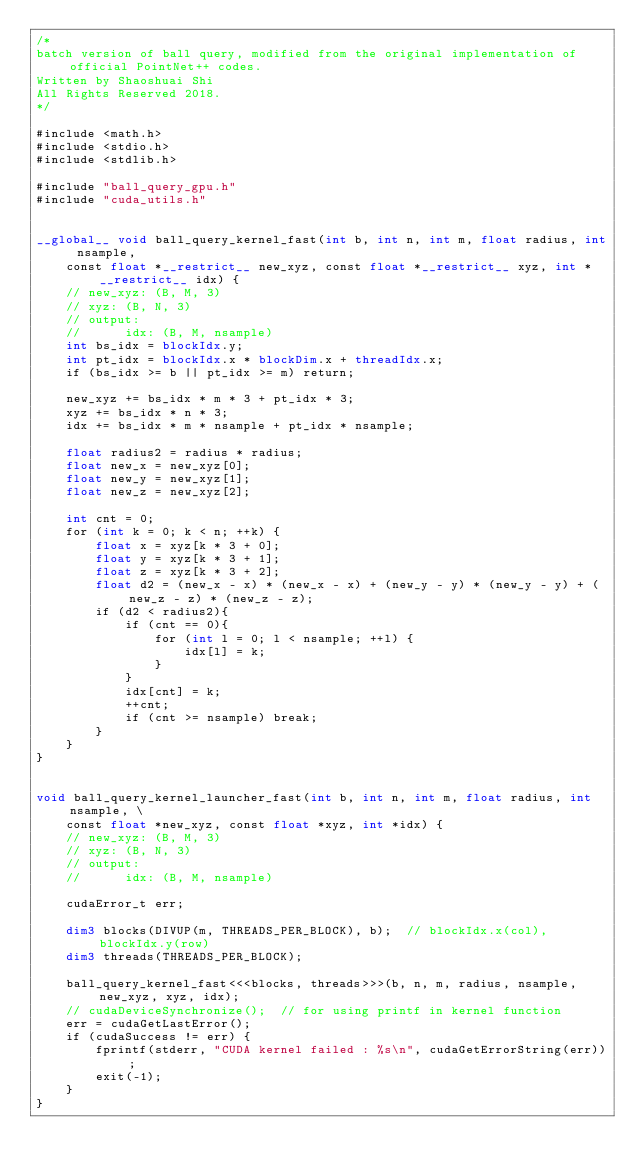Convert code to text. <code><loc_0><loc_0><loc_500><loc_500><_Cuda_>/*
batch version of ball query, modified from the original implementation of official PointNet++ codes.
Written by Shaoshuai Shi
All Rights Reserved 2018.
*/

#include <math.h>
#include <stdio.h>
#include <stdlib.h>

#include "ball_query_gpu.h"
#include "cuda_utils.h"


__global__ void ball_query_kernel_fast(int b, int n, int m, float radius, int nsample, 
    const float *__restrict__ new_xyz, const float *__restrict__ xyz, int *__restrict__ idx) {
    // new_xyz: (B, M, 3)
    // xyz: (B, N, 3)
    // output:
    //      idx: (B, M, nsample)
    int bs_idx = blockIdx.y;
    int pt_idx = blockIdx.x * blockDim.x + threadIdx.x;
    if (bs_idx >= b || pt_idx >= m) return;

    new_xyz += bs_idx * m * 3 + pt_idx * 3;
    xyz += bs_idx * n * 3;
    idx += bs_idx * m * nsample + pt_idx * nsample;

    float radius2 = radius * radius;
    float new_x = new_xyz[0];
    float new_y = new_xyz[1];
    float new_z = new_xyz[2];

    int cnt = 0;
    for (int k = 0; k < n; ++k) {
        float x = xyz[k * 3 + 0];
        float y = xyz[k * 3 + 1];
        float z = xyz[k * 3 + 2];
        float d2 = (new_x - x) * (new_x - x) + (new_y - y) * (new_y - y) + (new_z - z) * (new_z - z);
        if (d2 < radius2){
            if (cnt == 0){
                for (int l = 0; l < nsample; ++l) {
                    idx[l] = k;
                }
            }
            idx[cnt] = k;
            ++cnt;
            if (cnt >= nsample) break;
        }
    }
}


void ball_query_kernel_launcher_fast(int b, int n, int m, float radius, int nsample, \
    const float *new_xyz, const float *xyz, int *idx) {
    // new_xyz: (B, M, 3)
    // xyz: (B, N, 3)
    // output:
    //      idx: (B, M, nsample)

    cudaError_t err;

    dim3 blocks(DIVUP(m, THREADS_PER_BLOCK), b);  // blockIdx.x(col), blockIdx.y(row)
    dim3 threads(THREADS_PER_BLOCK);

    ball_query_kernel_fast<<<blocks, threads>>>(b, n, m, radius, nsample, new_xyz, xyz, idx);
    // cudaDeviceSynchronize();  // for using printf in kernel function
    err = cudaGetLastError();
    if (cudaSuccess != err) {
        fprintf(stderr, "CUDA kernel failed : %s\n", cudaGetErrorString(err));
        exit(-1);
    }
}
</code> 